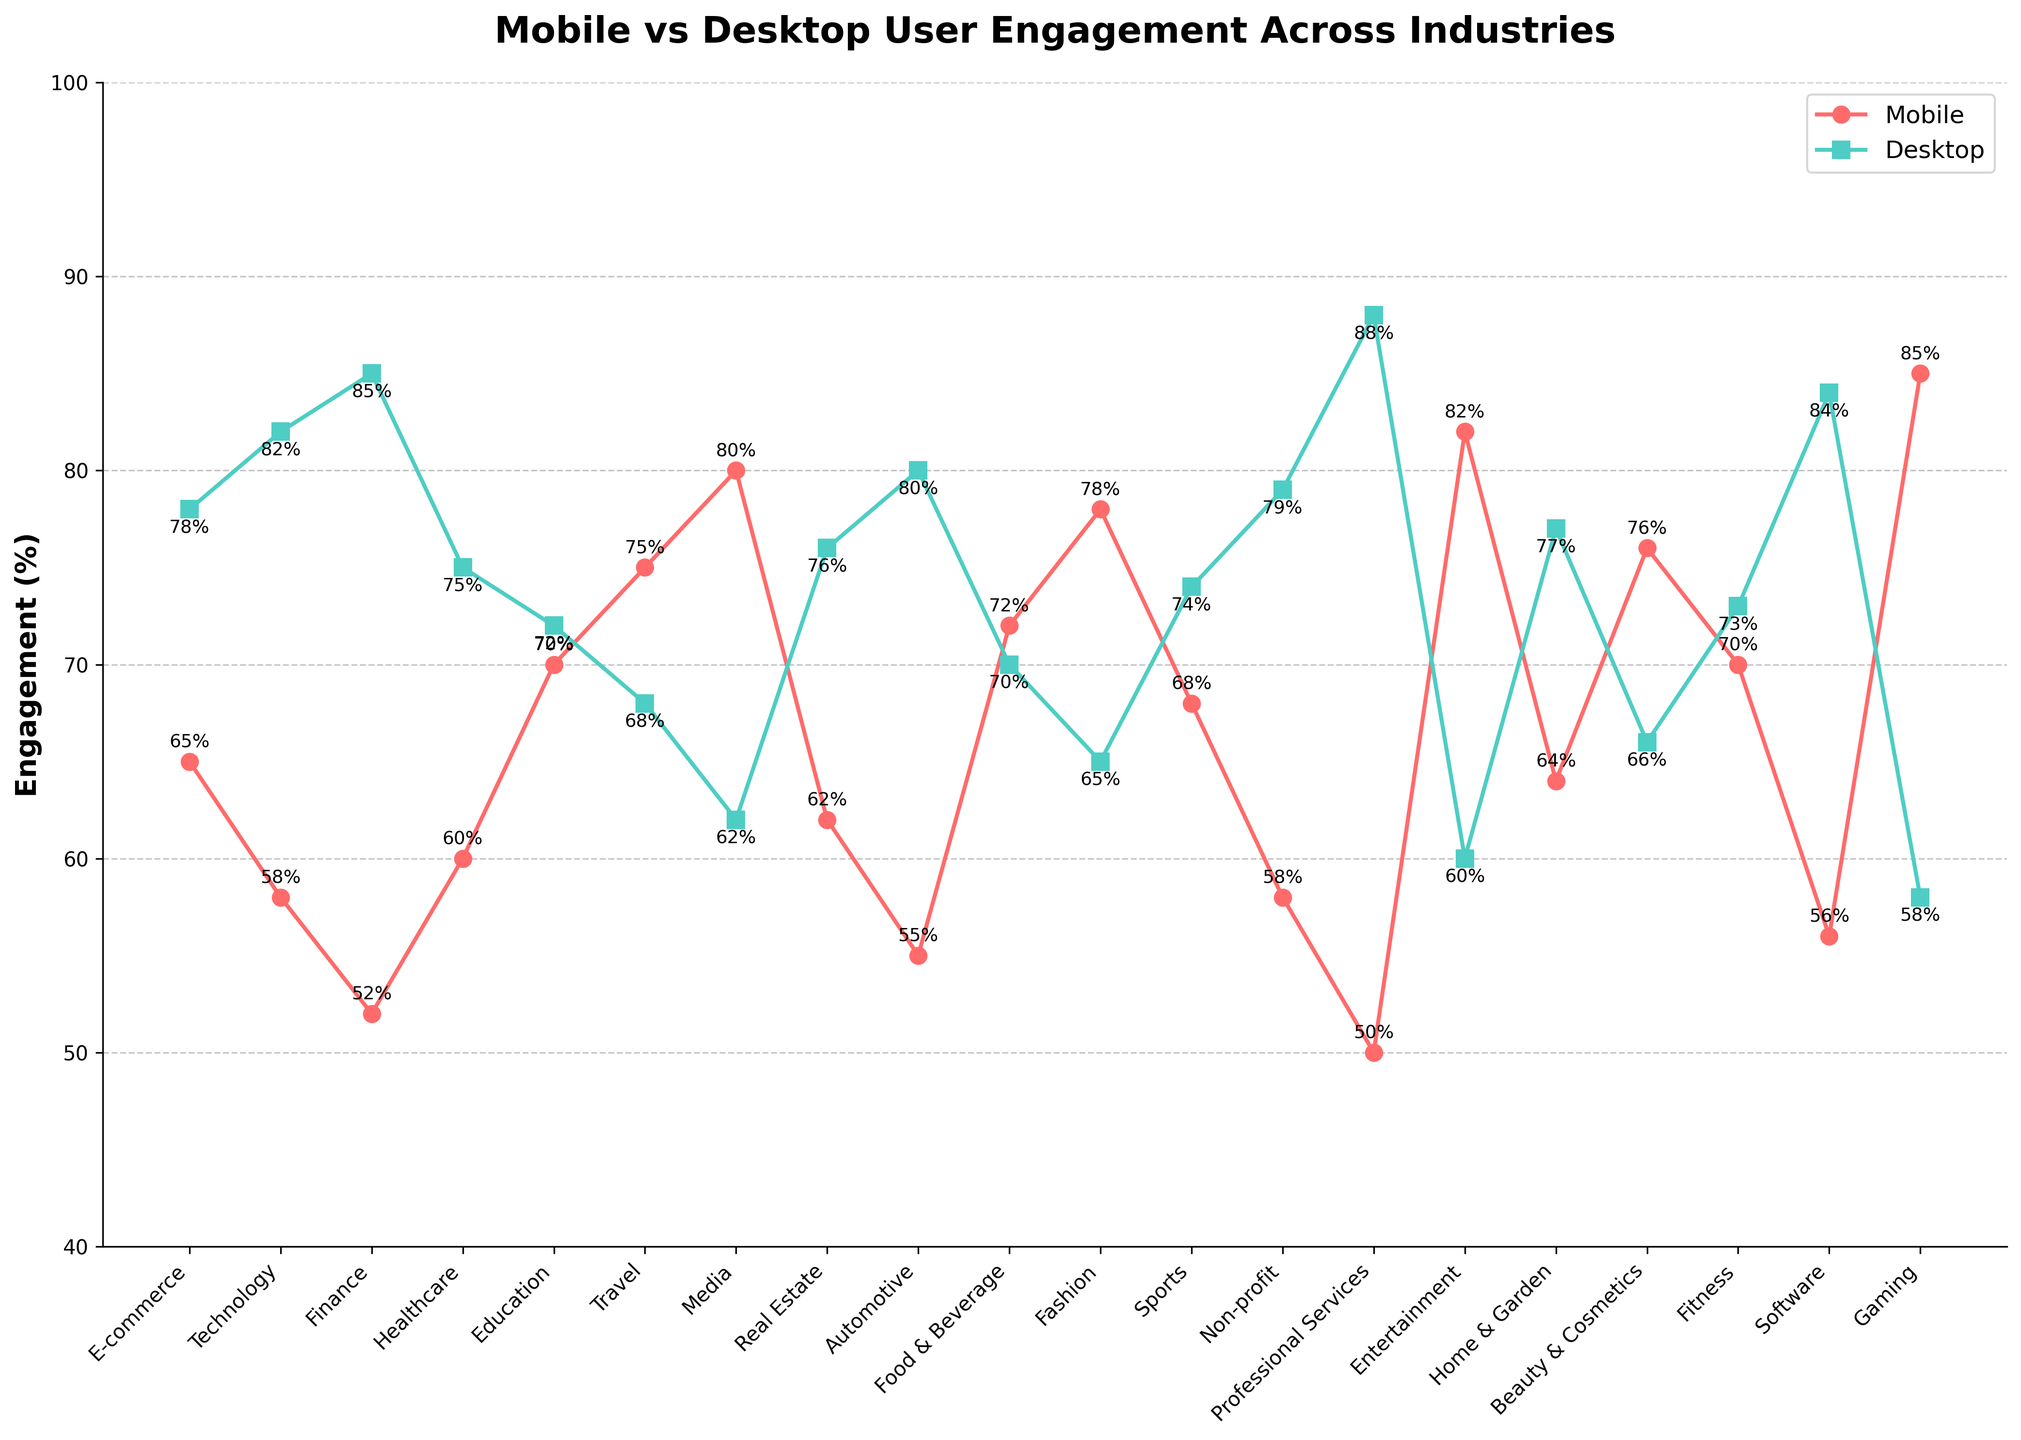What industry has the highest mobile engagement? Looking at the highest point on the red line (Mobile Engagement) and finding the corresponding industry, the highest value is 85%.
Answer: Gaming Which industry has a higher desktop engagement, E-commerce or Automotive? Looking at the green square markers for E-commerce and Automotive, E-commerce has 78% while Automotive has 80%.
Answer: Automotive What is the average mobile engagement across the Fashion, Gaming, and Media industries? Average is calculated by summing the values and dividing by the number of industries: (78 + 85 + 80) / 3 = 81%.
Answer: 81% Which industry shows the smallest difference between mobile and desktop engagement? The smallest difference can be found by checking each industry's engagement values and calculating the differences: Education (2%) is the smallest.
Answer: Education (2%) Is the mobile engagement in the Technology industry higher or lower than that in the Healthcare industry? Comparing the mobile engagement values: Technology (58%) vs Healthcare (60%).
Answer: Lower What’s the range of desktop engagement values? The range is the difference between the maximum and minimum values for desktop engagement: Max (Professional Services 88%) - Min (Entertainment 60%) = 28%.
Answer: 28% Are there any industries where mobile engagement is greater than desktop engagement? Checking for industries where the red line (Mobile) is above the green line (Desktop). Travel (75% vs 68%) and Media (80% vs 62%) stand out.
Answer: Yes How does the mobile engagement in the Finance industry compare to the Software industry? Mobile engagement in Finance is 52%, while in Software it is 56%.
Answer: Lower Which industry has the second highest desktop engagement? By ordering the industries based on desktop engagement values, the second highest is Finance with 85%, after Professional Services.
Answer: Finance What is the total mobile engagement across the E-commerce, Technology, and Finance industries? Adding the mobile engagement values: 65 + 58 + 52 = 175%.
Answer: 175% 